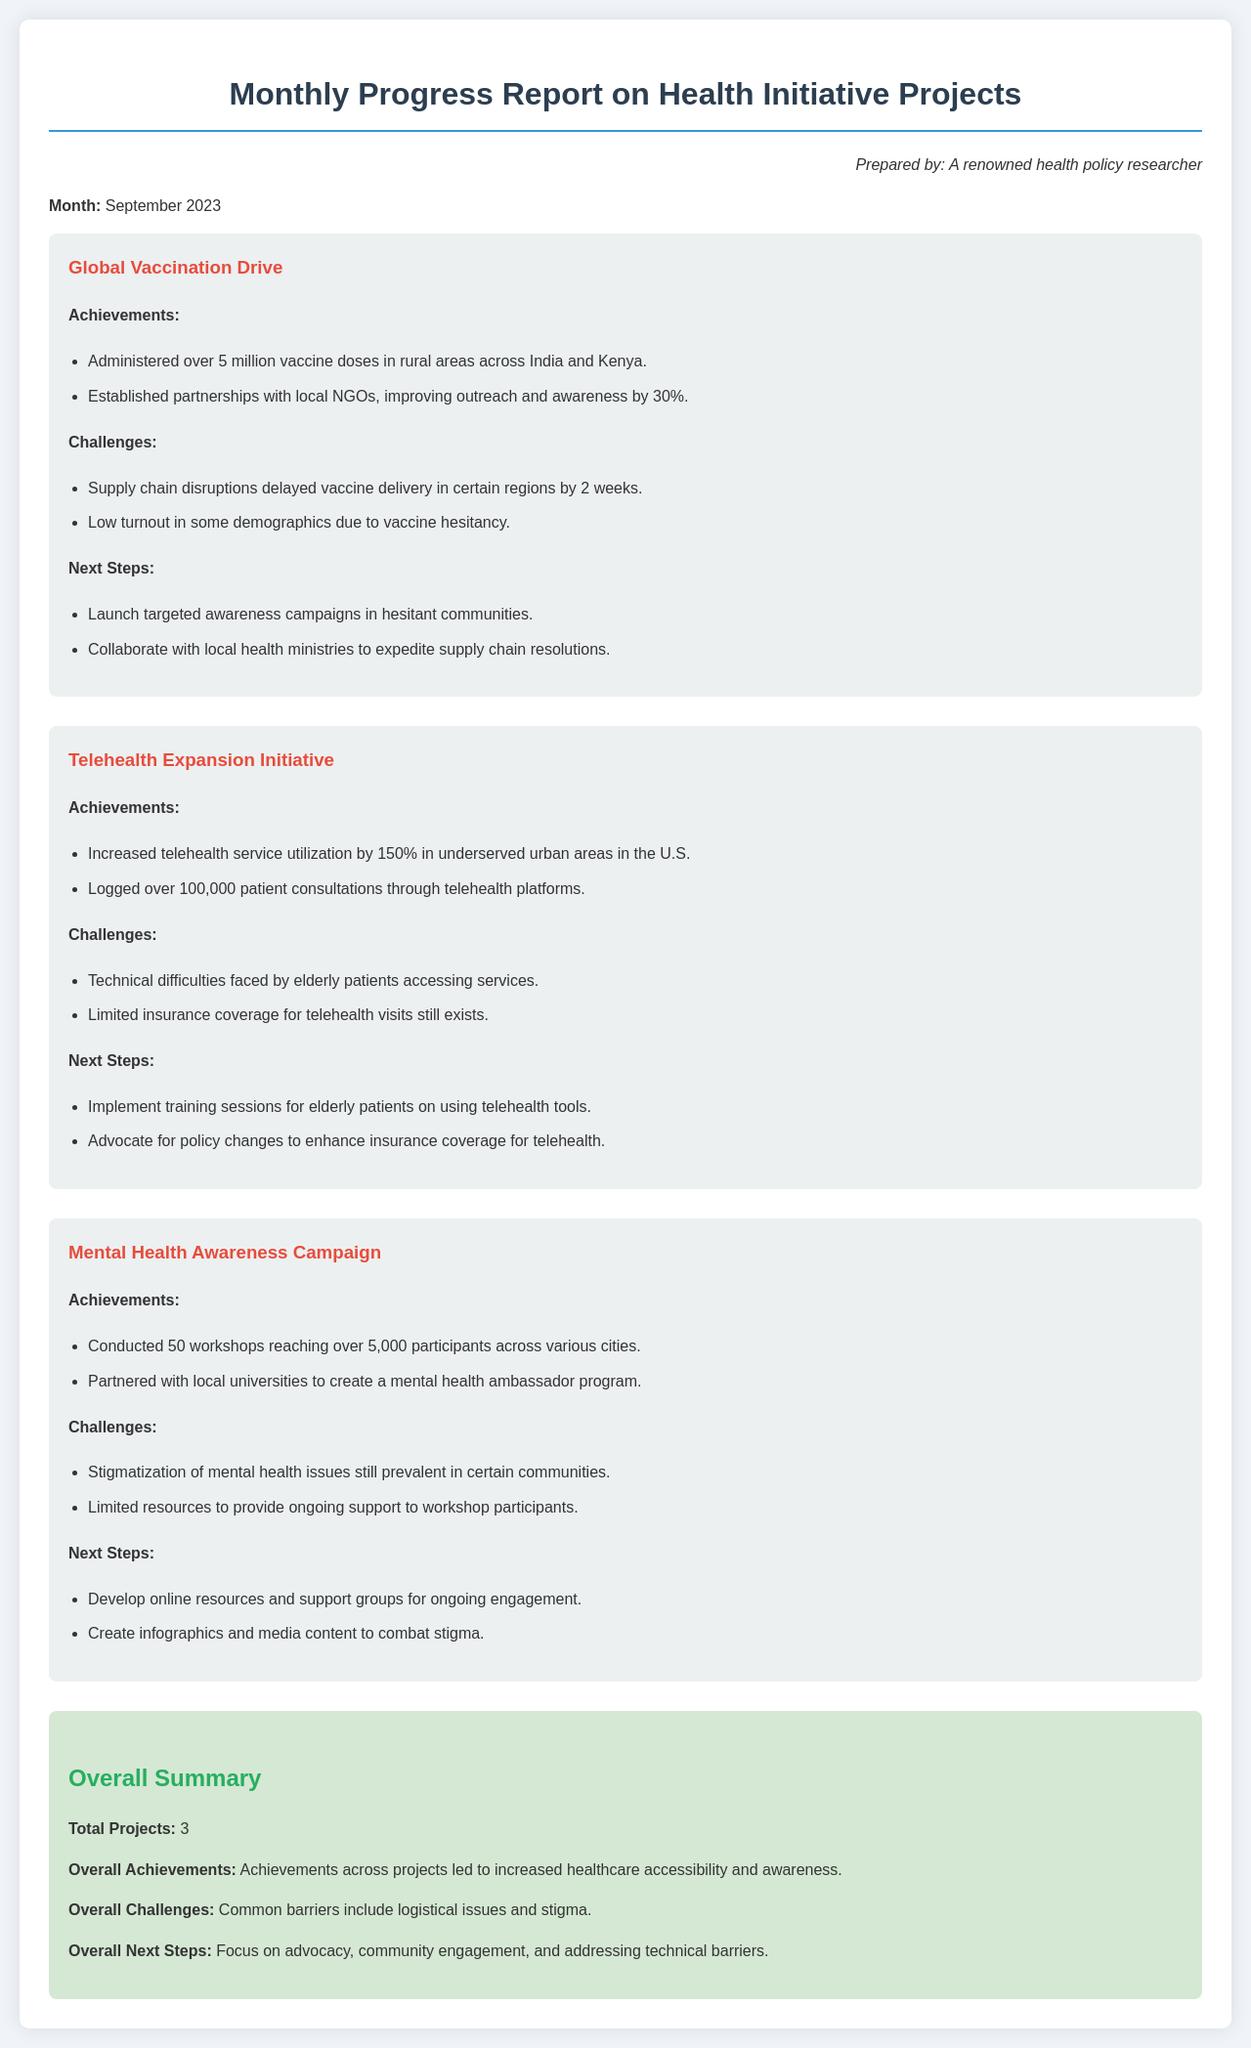What month is the report for? The document states that the report is prepared for September 2023.
Answer: September 2023 How many vaccine doses were administered in rural areas? The report mentions that over 5 million vaccine doses were administered in rural areas across India and Kenya.
Answer: Over 5 million What was the increase in telehealth service utilization? The document indicates that telehealth service utilization increased by 150% in underserved urban areas in the U.S.
Answer: 150% What challenge does the Global Vaccination Drive face? The document lists supply chain disruptions as a challenge that delayed vaccine delivery in certain regions.
Answer: Supply chain disruptions How many participants were reached through the Mental Health Awareness Campaign? According to the report, the campaign reached over 5,000 participants across various cities.
Answer: Over 5,000 What is the overall summary of challenges faced across projects? The document summarizes that common barriers include logistical issues and stigma.
Answer: Logistical issues and stigma What is the next step for the Telehealth Expansion Initiative? The report states that one of the next steps is to implement training sessions for elderly patients on using telehealth tools.
Answer: Implement training sessions What is a key achievement of the Mental Health Awareness Campaign? The report mentions that a key achievement was partnering with local universities to create a mental health ambassador program.
Answer: Mental health ambassador program 